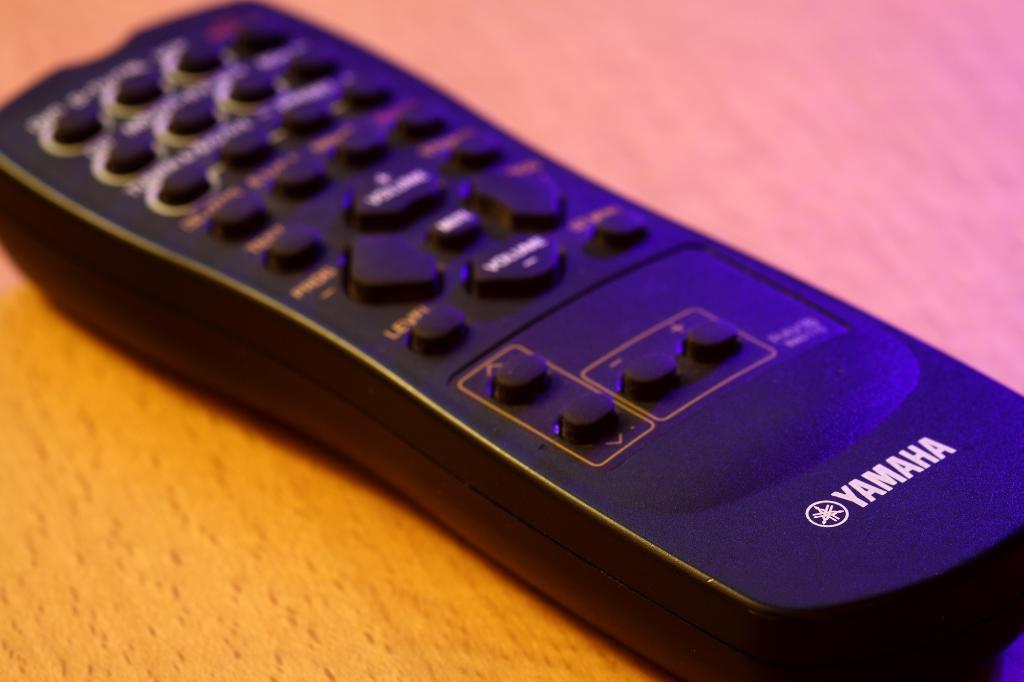Provide a one-sentence caption for the provided image. A remote control for a Yamaha device sits on a table. 